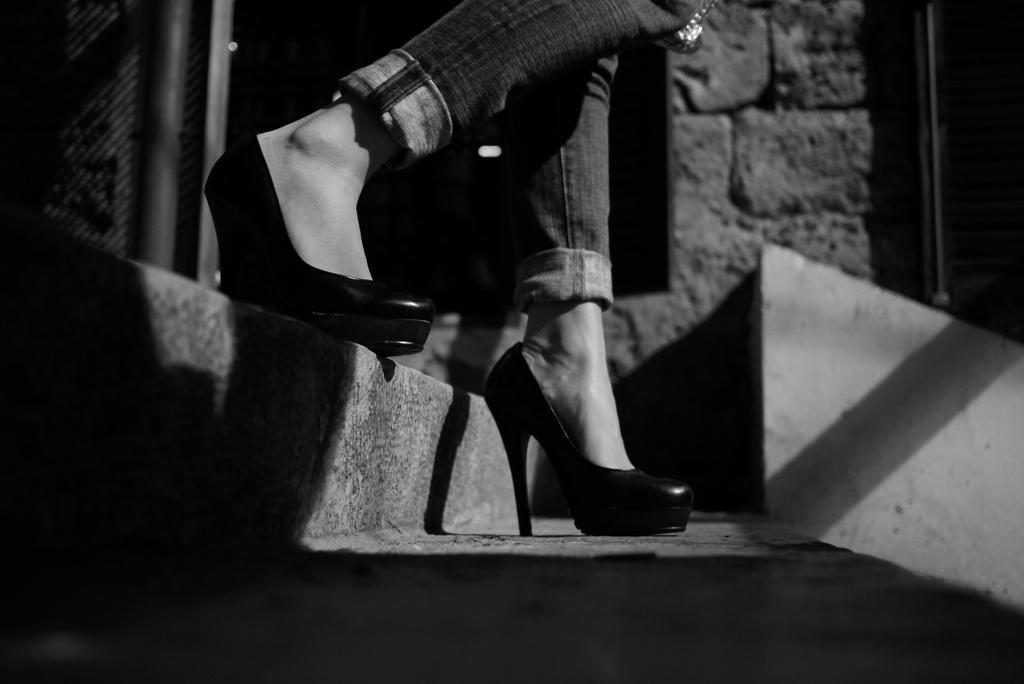In one or two sentences, can you explain what this image depicts? In this picture we can see a person's legs, on the left side there is a stair, we can see a wall in the background, it is a black and white image. 